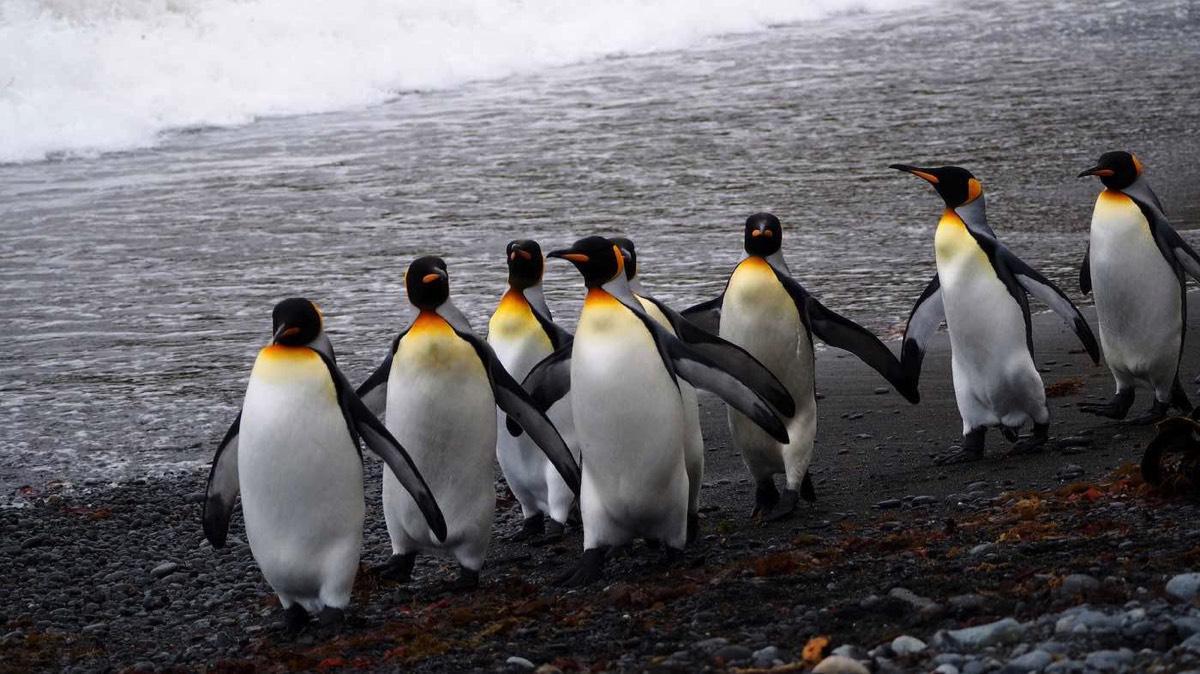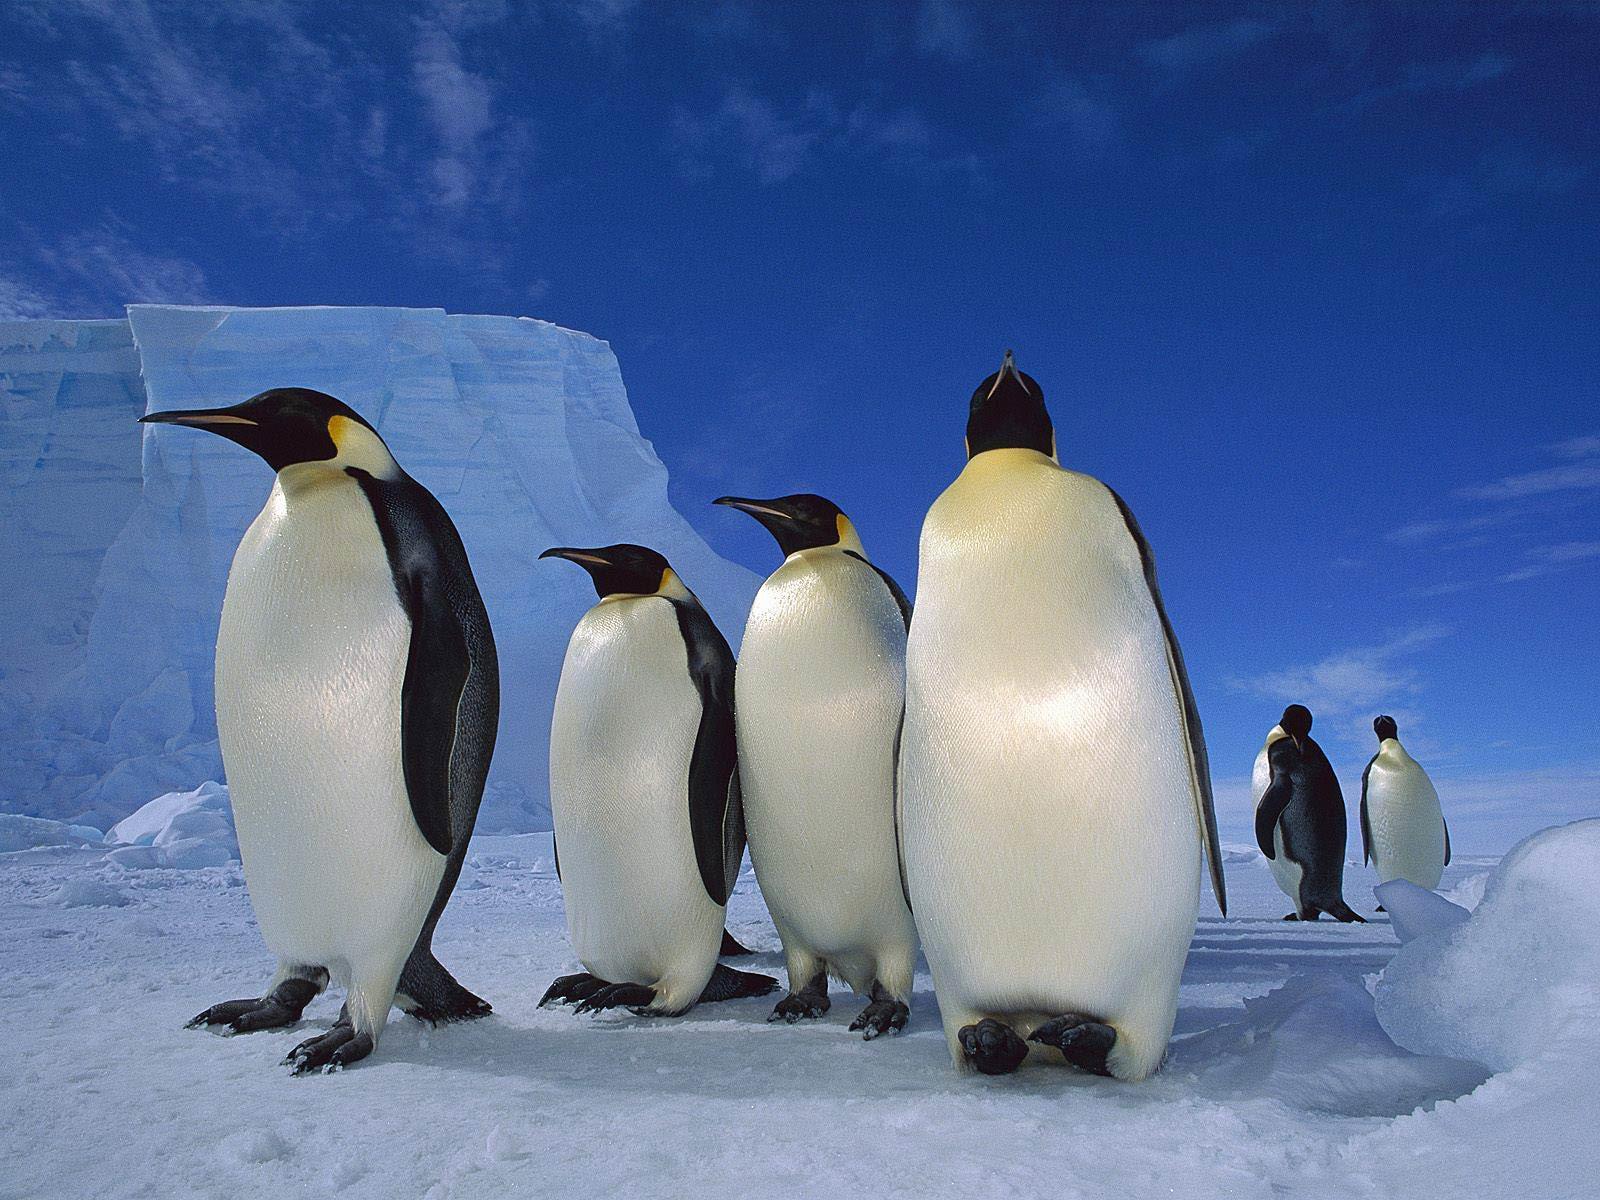The first image is the image on the left, the second image is the image on the right. Analyze the images presented: Is the assertion "At least one image has no more than two penguins." valid? Answer yes or no. No. 